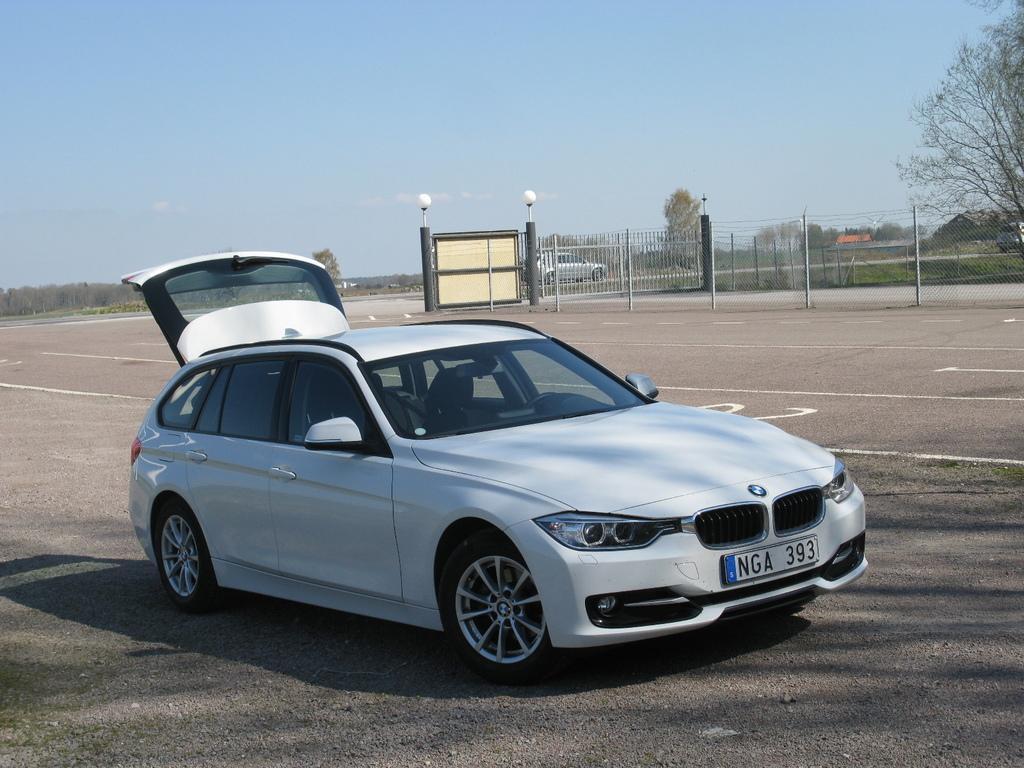Could you give a brief overview of what you see in this image? In this image we can see two cars in the two roads, some fences, two lights attached to the two pillars near to the gate, some objects on the ground, some wires, some poles, some trees, bushes, plants and grass on the ground. At the top there is the sky. 